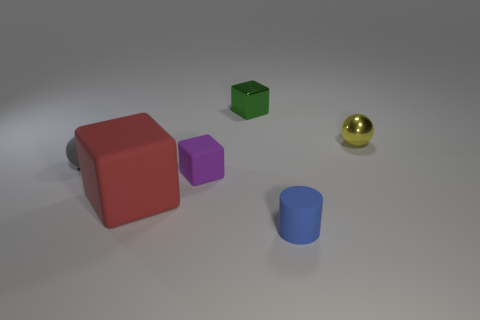Subtract all large matte blocks. How many blocks are left? 2 Add 2 large yellow rubber cylinders. How many objects exist? 8 Subtract 1 blocks. How many blocks are left? 2 Subtract all balls. How many objects are left? 4 Subtract all red cylinders. Subtract all purple spheres. How many cylinders are left? 1 Subtract all big rubber spheres. Subtract all gray spheres. How many objects are left? 5 Add 4 tiny matte things. How many tiny matte things are left? 7 Add 1 red rubber cylinders. How many red rubber cylinders exist? 1 Subtract 0 purple balls. How many objects are left? 6 